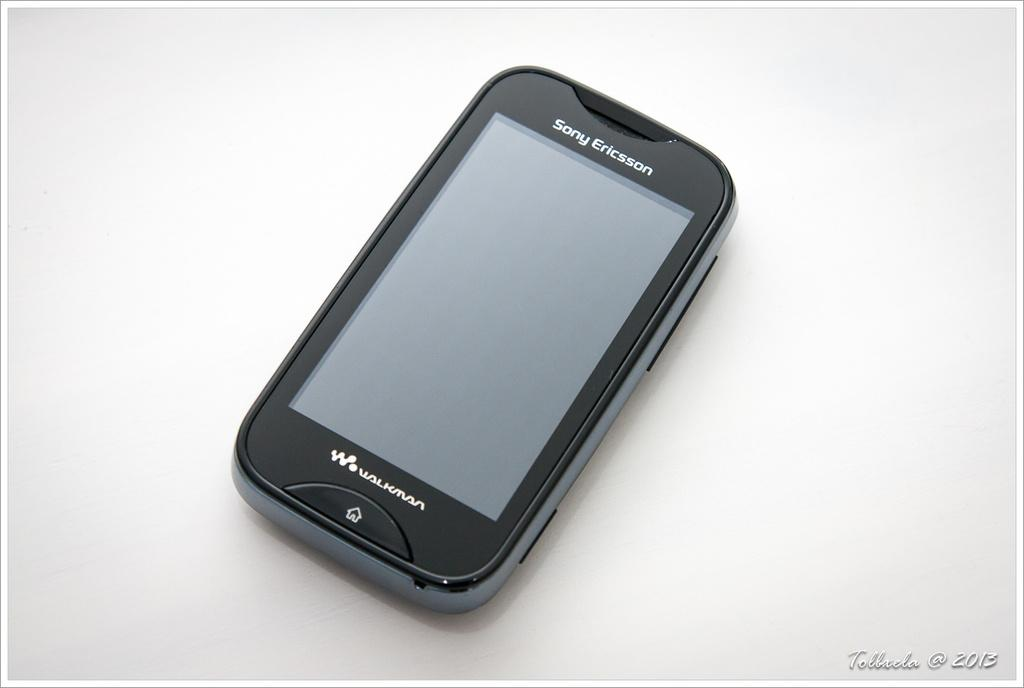<image>
Write a terse but informative summary of the picture. A Sony Ericsson Walkman sits on a desk. 